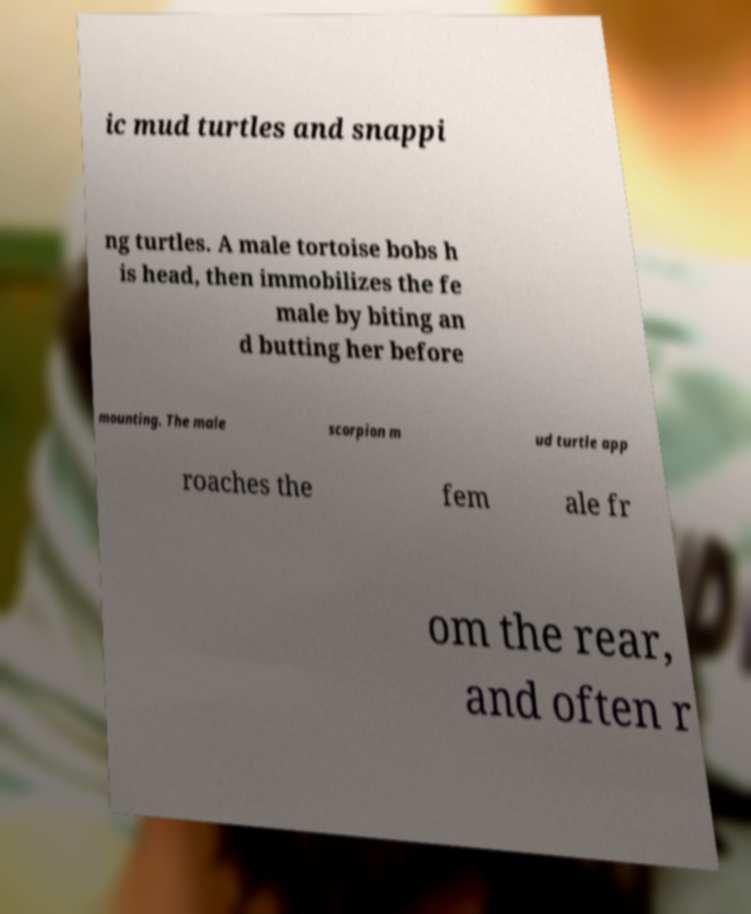Please read and relay the text visible in this image. What does it say? ic mud turtles and snappi ng turtles. A male tortoise bobs h is head, then immobilizes the fe male by biting an d butting her before mounting. The male scorpion m ud turtle app roaches the fem ale fr om the rear, and often r 